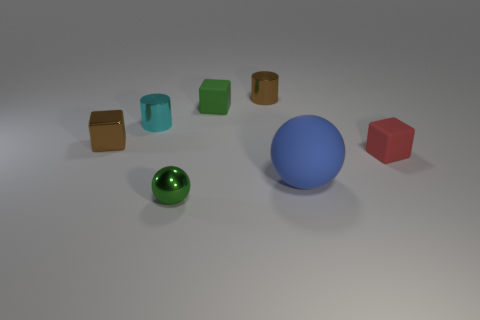Is there any other thing that has the same size as the blue rubber thing?
Your answer should be very brief. No. How many brown things are either small rubber cubes or cubes?
Keep it short and to the point. 1. What color is the small rubber block that is on the right side of the green object behind the small red rubber object?
Provide a succinct answer. Red. There is a block that is the same color as the small ball; what is its material?
Provide a succinct answer. Rubber. There is a cylinder that is on the left side of the brown cylinder; what color is it?
Your answer should be very brief. Cyan. Do the matte cube that is behind the red thing and the cyan metallic cylinder have the same size?
Offer a terse response. Yes. Are there any cyan cylinders of the same size as the green block?
Offer a very short reply. Yes. There is a shiny object to the right of the green matte block; is it the same color as the small matte cube on the right side of the green cube?
Give a very brief answer. No. Are there any matte objects that have the same color as the tiny metallic sphere?
Make the answer very short. Yes. What number of other things are the same shape as the blue thing?
Provide a short and direct response. 1. 